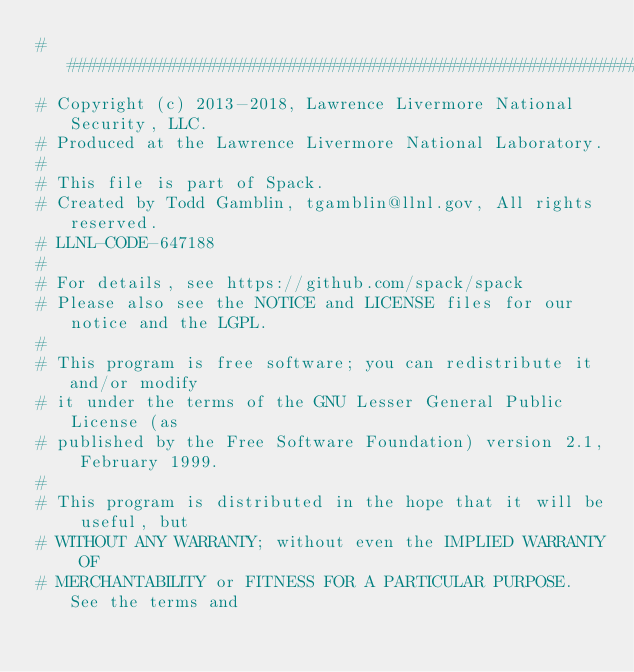Convert code to text. <code><loc_0><loc_0><loc_500><loc_500><_Python_>##############################################################################
# Copyright (c) 2013-2018, Lawrence Livermore National Security, LLC.
# Produced at the Lawrence Livermore National Laboratory.
#
# This file is part of Spack.
# Created by Todd Gamblin, tgamblin@llnl.gov, All rights reserved.
# LLNL-CODE-647188
#
# For details, see https://github.com/spack/spack
# Please also see the NOTICE and LICENSE files for our notice and the LGPL.
#
# This program is free software; you can redistribute it and/or modify
# it under the terms of the GNU Lesser General Public License (as
# published by the Free Software Foundation) version 2.1, February 1999.
#
# This program is distributed in the hope that it will be useful, but
# WITHOUT ANY WARRANTY; without even the IMPLIED WARRANTY OF
# MERCHANTABILITY or FITNESS FOR A PARTICULAR PURPOSE. See the terms and</code> 